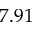Convert formula to latex. <formula><loc_0><loc_0><loc_500><loc_500>7 . 9 1</formula> 